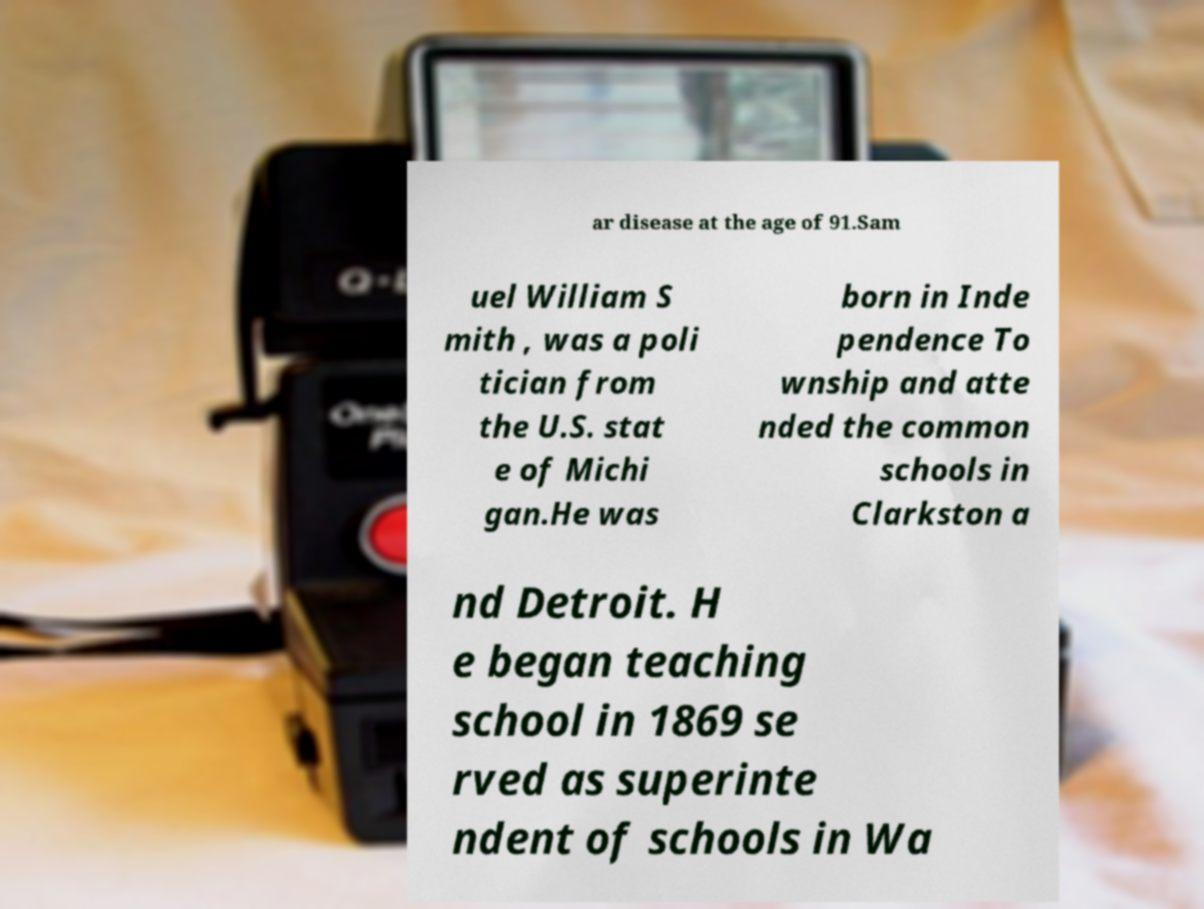Could you extract and type out the text from this image? ar disease at the age of 91.Sam uel William S mith , was a poli tician from the U.S. stat e of Michi gan.He was born in Inde pendence To wnship and atte nded the common schools in Clarkston a nd Detroit. H e began teaching school in 1869 se rved as superinte ndent of schools in Wa 